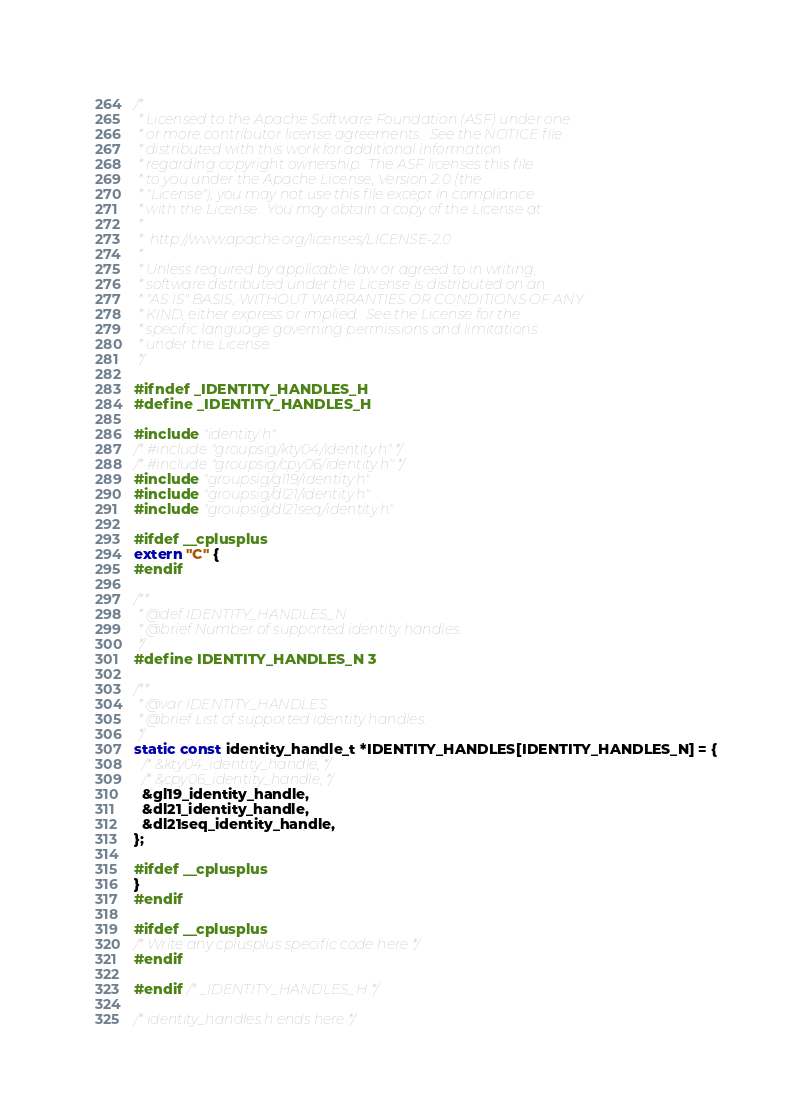<code> <loc_0><loc_0><loc_500><loc_500><_C_>/* 
 * Licensed to the Apache Software Foundation (ASF) under one
 * or more contributor license agreements.  See the NOTICE file
 * distributed with this work for additional information
 * regarding copyright ownership.  The ASF licenses this file
 * to you under the Apache License, Version 2.0 (the
 * "License"); you may not use this file except in compliance
 * with the License.  You may obtain a copy of the License at
 *
 *  http://www.apache.org/licenses/LICENSE-2.0
 *
 * Unless required by applicable law or agreed to in writing,
 * software distributed under the License is distributed on an
 * "AS IS" BASIS, WITHOUT WARRANTIES OR CONDITIONS OF ANY
 * KIND, either express or implied.  See the License for the
 * specific language governing permissions and limitations
 * under the License.
 */

#ifndef _IDENTITY_HANDLES_H
#define _IDENTITY_HANDLES_H

#include "identity.h"
/* #include "groupsig/kty04/identity.h" */
/* #include "groupsig/cpy06/identity.h" */
#include "groupsig/gl19/identity.h"
#include "groupsig/dl21/identity.h"
#include "groupsig/dl21seq/identity.h"

#ifdef __cplusplus
extern "C" {
#endif

/**
 * @def IDENTITY_HANDLES_N
 * @brief Number of supported identity handles.
 */
#define IDENTITY_HANDLES_N 3

/**
 * @var IDENTITY_HANDLES
 * @brief List of supported identity handles.
 */
static const identity_handle_t *IDENTITY_HANDLES[IDENTITY_HANDLES_N] = {
  /* &kty04_identity_handle, */
  /* &cpy06_identity_handle, */
  &gl19_identity_handle,
  &dl21_identity_handle,
  &dl21seq_identity_handle,  
};

#ifdef __cplusplus
}
#endif

#ifdef __cplusplus
/* Write any cplusplus specific code here */
#endif
  
#endif /* _IDENTITY_HANDLES_H */

/* identity_handles.h ends here */
</code> 